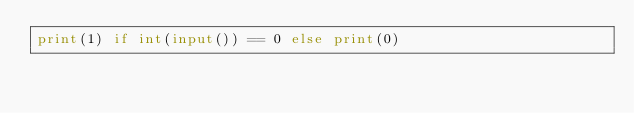<code> <loc_0><loc_0><loc_500><loc_500><_Python_>print(1) if int(input()) == 0 else print(0)</code> 